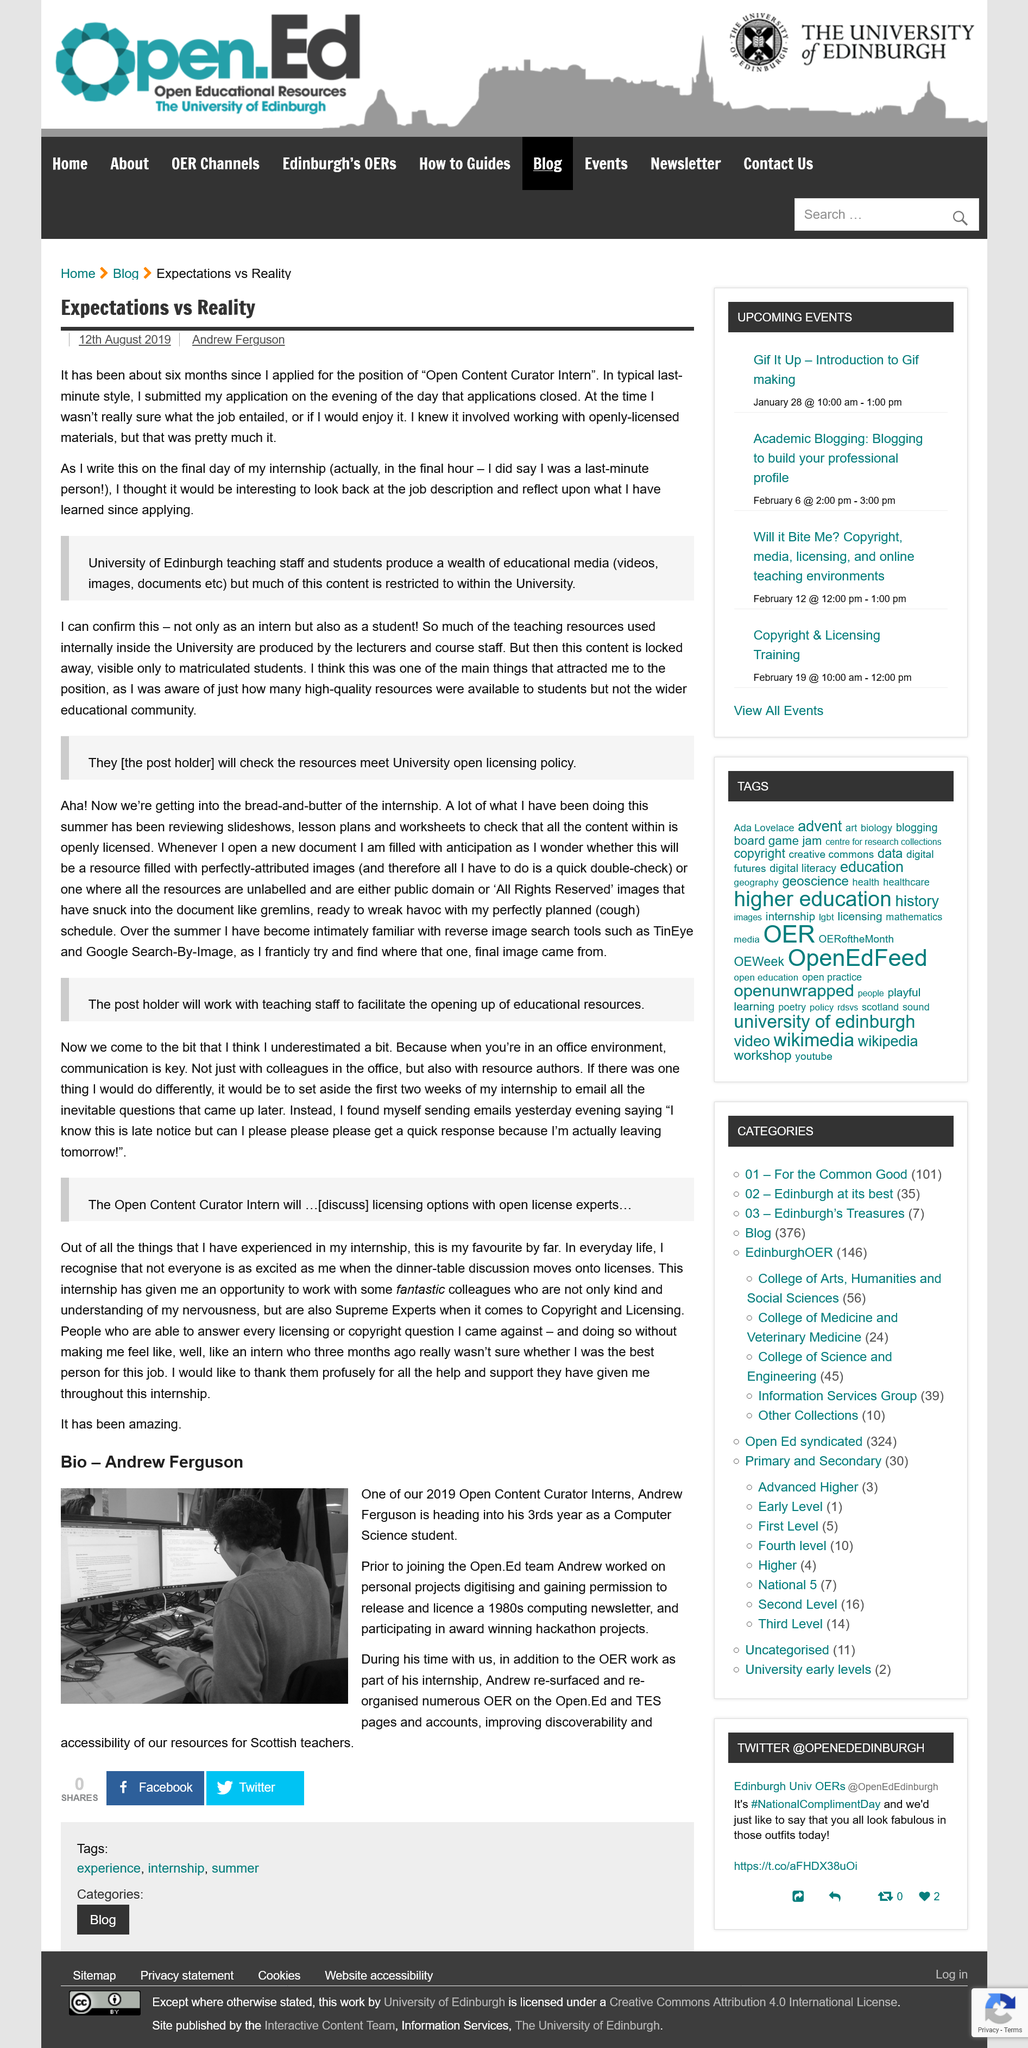Draw attention to some important aspects in this diagram. Andrew Ferguson is the person whose first and last name is mentioned above the image. Communication is the crucial element in the office environment, as it ensures the effective exchange of information and ideas among employees, thereby promoting productivity and collaboration. The educational content is available to matriculated students of the University. The author applied for the position of open content creator intern. The post holder will be responsible for ensuring that the resources meet the University's open licensing policy and for collaborating with teaching staff to promote the sharing of educational materials. 